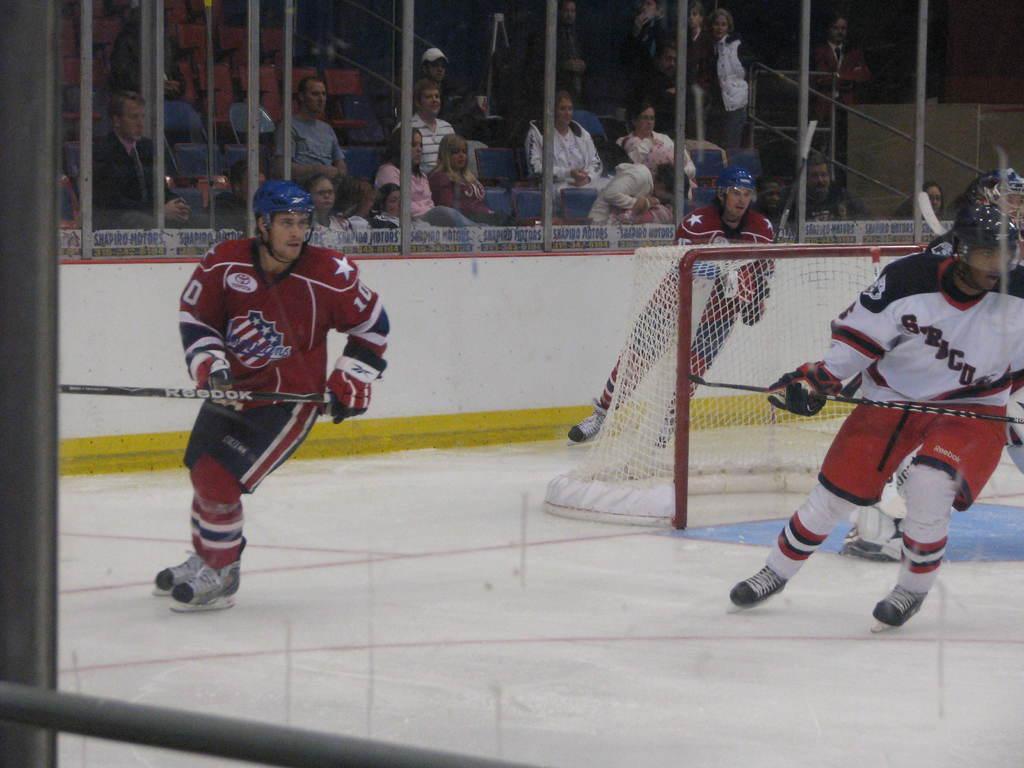Please provide a concise description of this image. In the center of the image we can see three persons are skating and they are holding sticks. And we can see they are wearing helmets. In the middle of the image, there is a net. In the background, we can see poles, banners, chairs, few people are standing, few people are sitting and few other objects. 